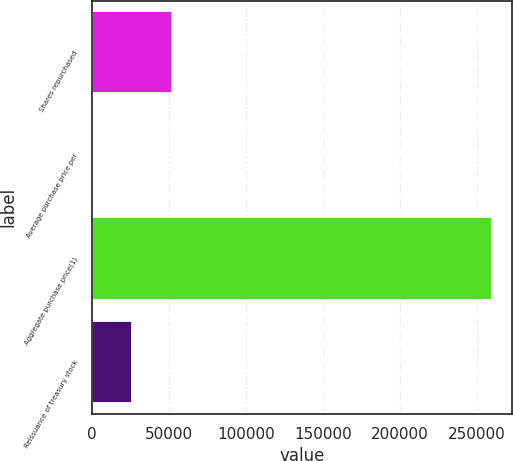Convert chart to OTSL. <chart><loc_0><loc_0><loc_500><loc_500><bar_chart><fcel>Shares repurchased<fcel>Average purchase price per<fcel>Aggregate purchase price(1)<fcel>Reissuance of treasury stock<nl><fcel>52036.7<fcel>45.84<fcel>260000<fcel>26041.3<nl></chart> 